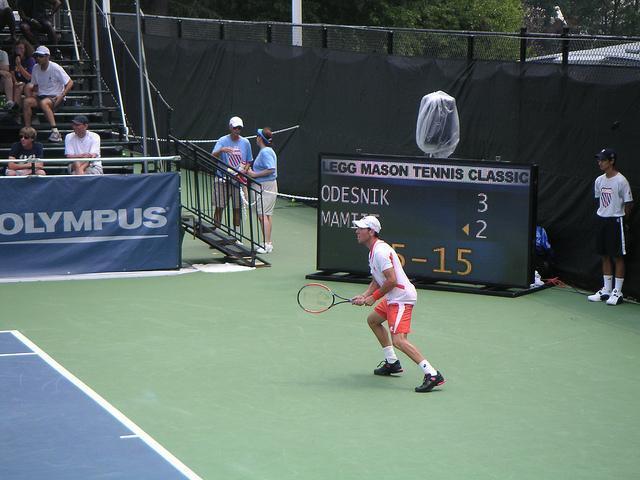How many people can be seen?
Give a very brief answer. 5. 